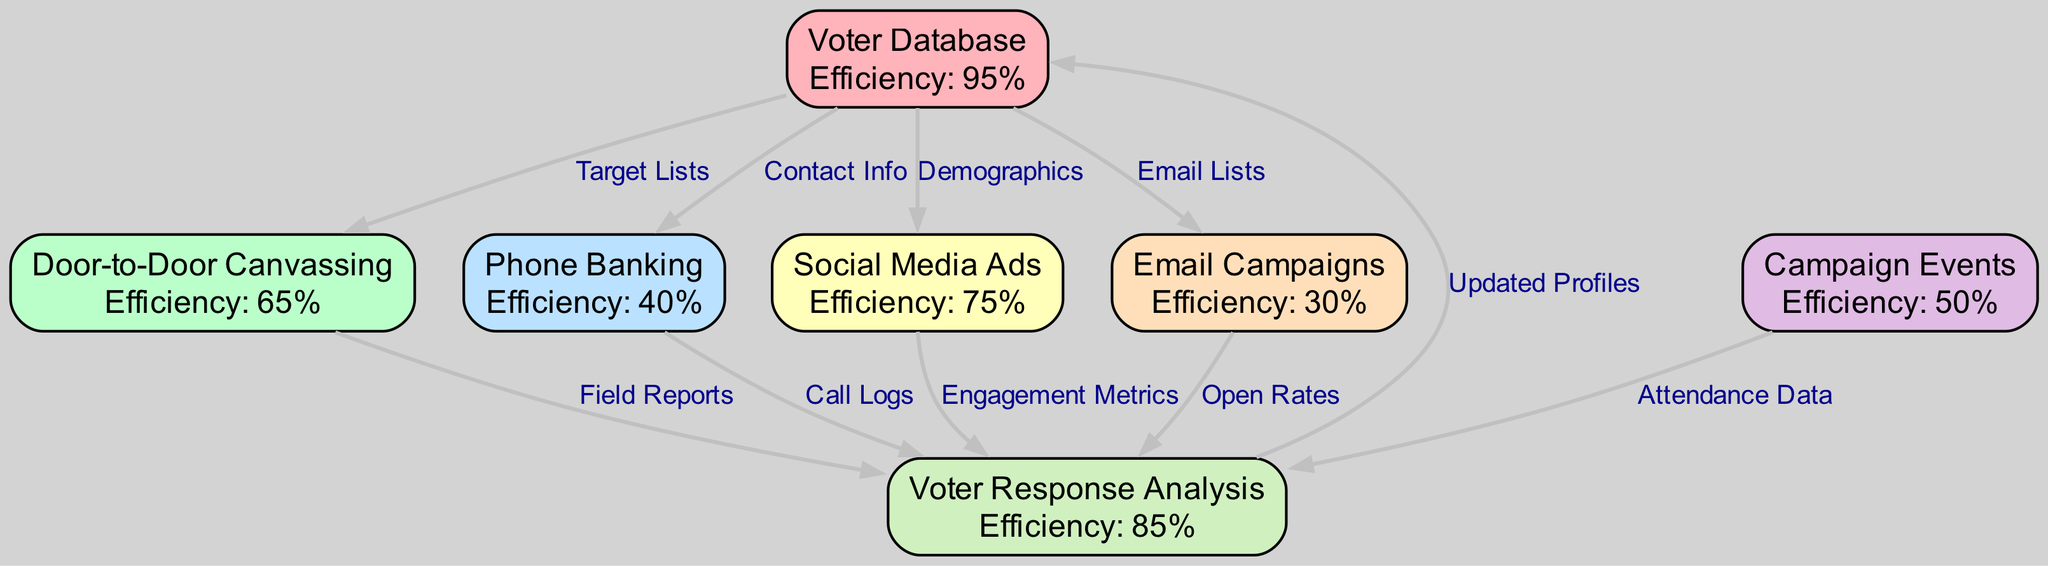What is the efficiency of Door-to-Door Canvassing? The diagram clearly indicates that the efficiency metric for Door-to-Door Canvassing is 65%. This information can be found directly within the node labeled "Door-to-Door Canvassing."
Answer: 65% What is the primary relationship between the Voter Database and Phone Banking? The diagram shows that the Voter Database is linked to Phone Banking through the edge labeled "Contact Info." This indicates that contact information derived from the voter database is utilized for phone banking efforts.
Answer: Contact Info How many total outreach methods are represented in the diagram? By counting the nodes labeled as outreach methods, we find there are six distinct methods: Door-to-Door Canvassing, Phone Banking, Social Media Ads, Email Campaigns, Campaign Events, and Voter Response Analysis.
Answer: 6 Which outreach method has the highest efficiency? The Voter Database node displays an efficiency of 95%, which is higher than all other outreach methods listed in the diagram, making it the most efficient overall.
Answer: 95% What edge connects Campaign Events to Voter Response Analysis? The diagram indicates that the edge connecting Campaign Events to Voter Response Analysis is labeled "Attendance Data." This suggests that the analysis of voter responses is informed by the data collected regarding attendance at campaign events.
Answer: Attendance Data Which outreach method has the lowest efficiency rating? The Email Campaigns node in the diagram shows an efficiency rating of 30%, which is the lowest among all the outreach methods presented.
Answer: 30% How does Voter Response Analysis impact the Voter Database? The diagram illustrates that Voter Response Analysis, influenced by various outreach methods, eventually feeds updated profiles back into the Voter Database. This indicates a feedback loop where voter analysis helps to refine the database.
Answer: Updated Profiles What is the efficiency of Social Media Ads? The diagram shows the efficiency for Social Media Ads is recorded at 75%. This value highlights its effectiveness as an outreach method compared to others.
Answer: 75% What are the metrics used to analyze Voter Response? The diagram outlines several types of data used in Voter Response Analysis, including Field Reports from Door-to-Door Canvassing, Call Logs from Phone Banking, Engagement Metrics from Social Media Ads, Open Rates from Email Campaigns, and Attendance Data from Campaign Events.
Answer: Field Reports, Call Logs, Engagement Metrics, Open Rates, Attendance Data 